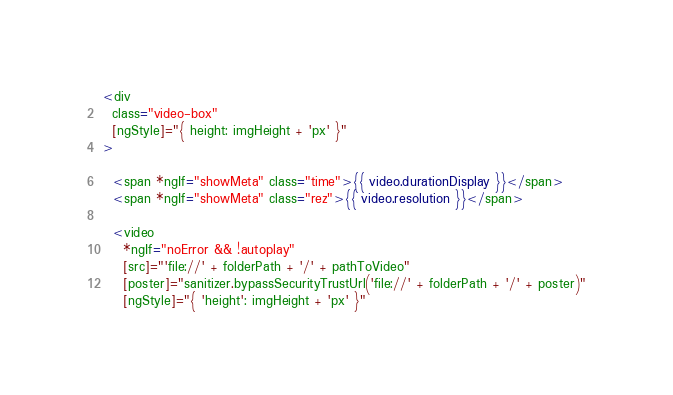Convert code to text. <code><loc_0><loc_0><loc_500><loc_500><_HTML_>
<div
  class="video-box"
  [ngStyle]="{ height: imgHeight + 'px' }"
>

  <span *ngIf="showMeta" class="time">{{ video.durationDisplay }}</span>
  <span *ngIf="showMeta" class="rez">{{ video.resolution }}</span>

  <video
    *ngIf="noError && !autoplay"
    [src]="'file://' + folderPath + '/' + pathToVideo"
    [poster]="sanitizer.bypassSecurityTrustUrl('file://' + folderPath + '/' + poster)"
    [ngStyle]="{ 'height': imgHeight + 'px' }"</code> 